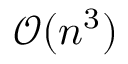Convert formula to latex. <formula><loc_0><loc_0><loc_500><loc_500>\mathcal { O } ( n ^ { 3 } )</formula> 